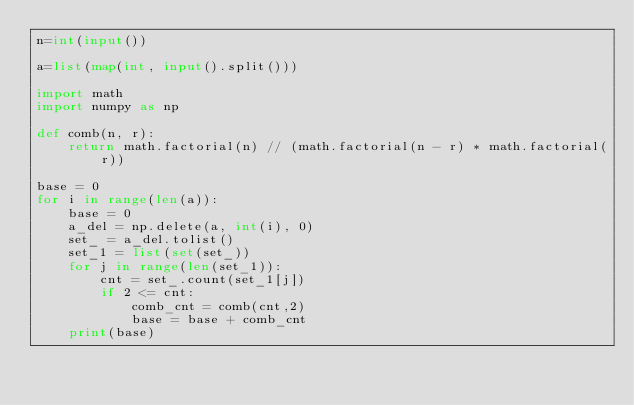Convert code to text. <code><loc_0><loc_0><loc_500><loc_500><_Python_>n=int(input())
 
a=list(map(int, input().split()))

import math
import numpy as np

def comb(n, r):
    return math.factorial(n) // (math.factorial(n - r) * math.factorial(r))
  
base = 0
for i in range(len(a)):
    base = 0
    a_del = np.delete(a, int(i), 0)
    set_ = a_del.tolist()
    set_1 = list(set(set_))
    for j in range(len(set_1)):
        cnt = set_.count(set_1[j])
        if 2 <= cnt:
            comb_cnt = comb(cnt,2)
            base = base + comb_cnt
    print(base)</code> 